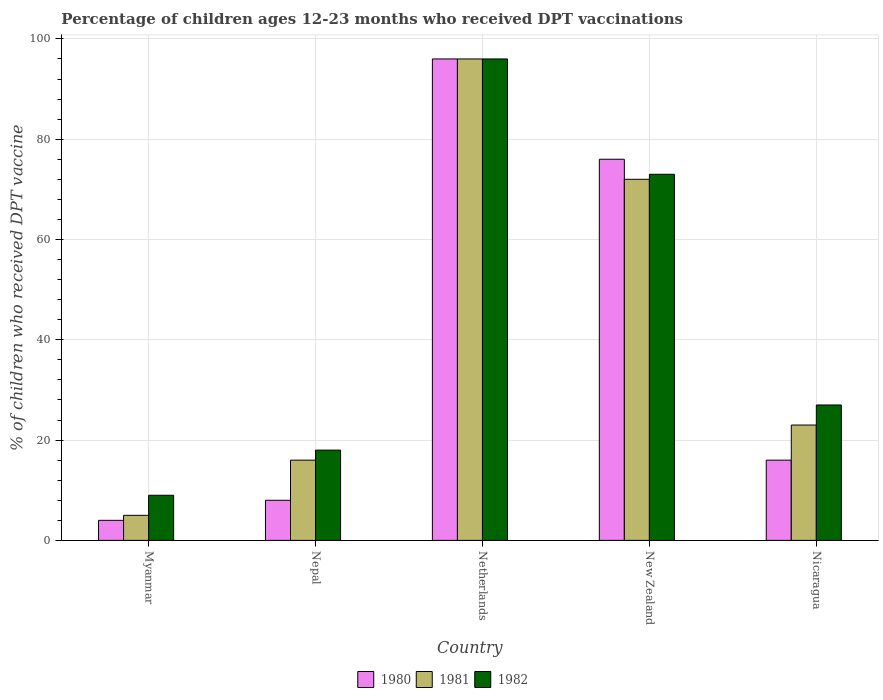How many bars are there on the 5th tick from the right?
Your answer should be very brief. 3. What is the label of the 5th group of bars from the left?
Ensure brevity in your answer.  Nicaragua. Across all countries, what is the maximum percentage of children who received DPT vaccination in 1982?
Make the answer very short. 96. In which country was the percentage of children who received DPT vaccination in 1980 minimum?
Provide a succinct answer. Myanmar. What is the total percentage of children who received DPT vaccination in 1981 in the graph?
Provide a succinct answer. 212. What is the average percentage of children who received DPT vaccination in 1982 per country?
Offer a very short reply. 44.6. What is the difference between the percentage of children who received DPT vaccination of/in 1981 and percentage of children who received DPT vaccination of/in 1982 in Nepal?
Ensure brevity in your answer.  -2. What is the ratio of the percentage of children who received DPT vaccination in 1980 in Myanmar to that in New Zealand?
Make the answer very short. 0.05. What is the difference between the highest and the lowest percentage of children who received DPT vaccination in 1980?
Ensure brevity in your answer.  92. Is the sum of the percentage of children who received DPT vaccination in 1980 in Nepal and New Zealand greater than the maximum percentage of children who received DPT vaccination in 1981 across all countries?
Your response must be concise. No. Are all the bars in the graph horizontal?
Ensure brevity in your answer.  No. How many countries are there in the graph?
Give a very brief answer. 5. What is the difference between two consecutive major ticks on the Y-axis?
Keep it short and to the point. 20. Does the graph contain any zero values?
Make the answer very short. No. What is the title of the graph?
Give a very brief answer. Percentage of children ages 12-23 months who received DPT vaccinations. What is the label or title of the Y-axis?
Make the answer very short. % of children who received DPT vaccine. What is the % of children who received DPT vaccine in 1981 in Myanmar?
Your answer should be compact. 5. What is the % of children who received DPT vaccine of 1980 in Nepal?
Your answer should be compact. 8. What is the % of children who received DPT vaccine in 1982 in Nepal?
Keep it short and to the point. 18. What is the % of children who received DPT vaccine in 1980 in Netherlands?
Offer a very short reply. 96. What is the % of children who received DPT vaccine in 1981 in Netherlands?
Give a very brief answer. 96. What is the % of children who received DPT vaccine in 1982 in Netherlands?
Your answer should be compact. 96. What is the % of children who received DPT vaccine in 1981 in New Zealand?
Provide a succinct answer. 72. What is the % of children who received DPT vaccine in 1982 in New Zealand?
Your answer should be very brief. 73. What is the % of children who received DPT vaccine in 1981 in Nicaragua?
Give a very brief answer. 23. What is the % of children who received DPT vaccine of 1982 in Nicaragua?
Make the answer very short. 27. Across all countries, what is the maximum % of children who received DPT vaccine in 1980?
Make the answer very short. 96. Across all countries, what is the maximum % of children who received DPT vaccine of 1981?
Your response must be concise. 96. Across all countries, what is the maximum % of children who received DPT vaccine of 1982?
Provide a succinct answer. 96. Across all countries, what is the minimum % of children who received DPT vaccine of 1980?
Offer a very short reply. 4. Across all countries, what is the minimum % of children who received DPT vaccine in 1981?
Keep it short and to the point. 5. Across all countries, what is the minimum % of children who received DPT vaccine in 1982?
Offer a very short reply. 9. What is the total % of children who received DPT vaccine of 1981 in the graph?
Make the answer very short. 212. What is the total % of children who received DPT vaccine of 1982 in the graph?
Your answer should be compact. 223. What is the difference between the % of children who received DPT vaccine in 1980 in Myanmar and that in Nepal?
Provide a short and direct response. -4. What is the difference between the % of children who received DPT vaccine in 1981 in Myanmar and that in Nepal?
Give a very brief answer. -11. What is the difference between the % of children who received DPT vaccine in 1980 in Myanmar and that in Netherlands?
Your answer should be compact. -92. What is the difference between the % of children who received DPT vaccine in 1981 in Myanmar and that in Netherlands?
Offer a terse response. -91. What is the difference between the % of children who received DPT vaccine of 1982 in Myanmar and that in Netherlands?
Ensure brevity in your answer.  -87. What is the difference between the % of children who received DPT vaccine in 1980 in Myanmar and that in New Zealand?
Give a very brief answer. -72. What is the difference between the % of children who received DPT vaccine in 1981 in Myanmar and that in New Zealand?
Your response must be concise. -67. What is the difference between the % of children who received DPT vaccine of 1982 in Myanmar and that in New Zealand?
Offer a terse response. -64. What is the difference between the % of children who received DPT vaccine of 1980 in Myanmar and that in Nicaragua?
Your answer should be very brief. -12. What is the difference between the % of children who received DPT vaccine in 1981 in Myanmar and that in Nicaragua?
Your answer should be very brief. -18. What is the difference between the % of children who received DPT vaccine of 1980 in Nepal and that in Netherlands?
Give a very brief answer. -88. What is the difference between the % of children who received DPT vaccine in 1981 in Nepal and that in Netherlands?
Your answer should be very brief. -80. What is the difference between the % of children who received DPT vaccine of 1982 in Nepal and that in Netherlands?
Provide a short and direct response. -78. What is the difference between the % of children who received DPT vaccine of 1980 in Nepal and that in New Zealand?
Offer a very short reply. -68. What is the difference between the % of children who received DPT vaccine in 1981 in Nepal and that in New Zealand?
Your answer should be very brief. -56. What is the difference between the % of children who received DPT vaccine in 1982 in Nepal and that in New Zealand?
Offer a terse response. -55. What is the difference between the % of children who received DPT vaccine in 1981 in Nepal and that in Nicaragua?
Provide a short and direct response. -7. What is the difference between the % of children who received DPT vaccine of 1980 in New Zealand and that in Nicaragua?
Provide a succinct answer. 60. What is the difference between the % of children who received DPT vaccine in 1981 in New Zealand and that in Nicaragua?
Your answer should be compact. 49. What is the difference between the % of children who received DPT vaccine of 1980 in Myanmar and the % of children who received DPT vaccine of 1981 in Nepal?
Your answer should be very brief. -12. What is the difference between the % of children who received DPT vaccine of 1981 in Myanmar and the % of children who received DPT vaccine of 1982 in Nepal?
Offer a very short reply. -13. What is the difference between the % of children who received DPT vaccine of 1980 in Myanmar and the % of children who received DPT vaccine of 1981 in Netherlands?
Keep it short and to the point. -92. What is the difference between the % of children who received DPT vaccine of 1980 in Myanmar and the % of children who received DPT vaccine of 1982 in Netherlands?
Provide a succinct answer. -92. What is the difference between the % of children who received DPT vaccine in 1981 in Myanmar and the % of children who received DPT vaccine in 1982 in Netherlands?
Your response must be concise. -91. What is the difference between the % of children who received DPT vaccine in 1980 in Myanmar and the % of children who received DPT vaccine in 1981 in New Zealand?
Offer a terse response. -68. What is the difference between the % of children who received DPT vaccine in 1980 in Myanmar and the % of children who received DPT vaccine in 1982 in New Zealand?
Provide a succinct answer. -69. What is the difference between the % of children who received DPT vaccine of 1981 in Myanmar and the % of children who received DPT vaccine of 1982 in New Zealand?
Keep it short and to the point. -68. What is the difference between the % of children who received DPT vaccine of 1980 in Myanmar and the % of children who received DPT vaccine of 1981 in Nicaragua?
Ensure brevity in your answer.  -19. What is the difference between the % of children who received DPT vaccine in 1980 in Myanmar and the % of children who received DPT vaccine in 1982 in Nicaragua?
Offer a very short reply. -23. What is the difference between the % of children who received DPT vaccine in 1981 in Myanmar and the % of children who received DPT vaccine in 1982 in Nicaragua?
Ensure brevity in your answer.  -22. What is the difference between the % of children who received DPT vaccine in 1980 in Nepal and the % of children who received DPT vaccine in 1981 in Netherlands?
Offer a very short reply. -88. What is the difference between the % of children who received DPT vaccine in 1980 in Nepal and the % of children who received DPT vaccine in 1982 in Netherlands?
Ensure brevity in your answer.  -88. What is the difference between the % of children who received DPT vaccine in 1981 in Nepal and the % of children who received DPT vaccine in 1982 in Netherlands?
Offer a very short reply. -80. What is the difference between the % of children who received DPT vaccine of 1980 in Nepal and the % of children who received DPT vaccine of 1981 in New Zealand?
Your response must be concise. -64. What is the difference between the % of children who received DPT vaccine of 1980 in Nepal and the % of children who received DPT vaccine of 1982 in New Zealand?
Offer a terse response. -65. What is the difference between the % of children who received DPT vaccine of 1981 in Nepal and the % of children who received DPT vaccine of 1982 in New Zealand?
Provide a succinct answer. -57. What is the difference between the % of children who received DPT vaccine of 1980 in Nepal and the % of children who received DPT vaccine of 1982 in Nicaragua?
Your answer should be very brief. -19. What is the difference between the % of children who received DPT vaccine in 1981 in Nepal and the % of children who received DPT vaccine in 1982 in Nicaragua?
Your response must be concise. -11. What is the difference between the % of children who received DPT vaccine in 1980 in Netherlands and the % of children who received DPT vaccine in 1981 in Nicaragua?
Your answer should be very brief. 73. What is the difference between the % of children who received DPT vaccine in 1980 in New Zealand and the % of children who received DPT vaccine in 1981 in Nicaragua?
Offer a very short reply. 53. What is the difference between the % of children who received DPT vaccine in 1981 in New Zealand and the % of children who received DPT vaccine in 1982 in Nicaragua?
Provide a short and direct response. 45. What is the average % of children who received DPT vaccine of 1980 per country?
Give a very brief answer. 40. What is the average % of children who received DPT vaccine in 1981 per country?
Ensure brevity in your answer.  42.4. What is the average % of children who received DPT vaccine of 1982 per country?
Give a very brief answer. 44.6. What is the difference between the % of children who received DPT vaccine of 1980 and % of children who received DPT vaccine of 1981 in Myanmar?
Give a very brief answer. -1. What is the difference between the % of children who received DPT vaccine in 1980 and % of children who received DPT vaccine in 1982 in Myanmar?
Keep it short and to the point. -5. What is the difference between the % of children who received DPT vaccine in 1981 and % of children who received DPT vaccine in 1982 in Myanmar?
Offer a very short reply. -4. What is the difference between the % of children who received DPT vaccine in 1980 and % of children who received DPT vaccine in 1981 in New Zealand?
Offer a terse response. 4. What is the difference between the % of children who received DPT vaccine of 1981 and % of children who received DPT vaccine of 1982 in New Zealand?
Provide a short and direct response. -1. What is the difference between the % of children who received DPT vaccine in 1980 and % of children who received DPT vaccine in 1981 in Nicaragua?
Keep it short and to the point. -7. What is the difference between the % of children who received DPT vaccine in 1980 and % of children who received DPT vaccine in 1982 in Nicaragua?
Keep it short and to the point. -11. What is the ratio of the % of children who received DPT vaccine of 1980 in Myanmar to that in Nepal?
Give a very brief answer. 0.5. What is the ratio of the % of children who received DPT vaccine of 1981 in Myanmar to that in Nepal?
Provide a succinct answer. 0.31. What is the ratio of the % of children who received DPT vaccine in 1982 in Myanmar to that in Nepal?
Your answer should be very brief. 0.5. What is the ratio of the % of children who received DPT vaccine in 1980 in Myanmar to that in Netherlands?
Give a very brief answer. 0.04. What is the ratio of the % of children who received DPT vaccine of 1981 in Myanmar to that in Netherlands?
Provide a short and direct response. 0.05. What is the ratio of the % of children who received DPT vaccine of 1982 in Myanmar to that in Netherlands?
Offer a terse response. 0.09. What is the ratio of the % of children who received DPT vaccine of 1980 in Myanmar to that in New Zealand?
Make the answer very short. 0.05. What is the ratio of the % of children who received DPT vaccine in 1981 in Myanmar to that in New Zealand?
Give a very brief answer. 0.07. What is the ratio of the % of children who received DPT vaccine in 1982 in Myanmar to that in New Zealand?
Offer a very short reply. 0.12. What is the ratio of the % of children who received DPT vaccine of 1981 in Myanmar to that in Nicaragua?
Ensure brevity in your answer.  0.22. What is the ratio of the % of children who received DPT vaccine in 1982 in Myanmar to that in Nicaragua?
Give a very brief answer. 0.33. What is the ratio of the % of children who received DPT vaccine in 1980 in Nepal to that in Netherlands?
Offer a terse response. 0.08. What is the ratio of the % of children who received DPT vaccine of 1981 in Nepal to that in Netherlands?
Your response must be concise. 0.17. What is the ratio of the % of children who received DPT vaccine in 1982 in Nepal to that in Netherlands?
Your answer should be very brief. 0.19. What is the ratio of the % of children who received DPT vaccine of 1980 in Nepal to that in New Zealand?
Offer a very short reply. 0.11. What is the ratio of the % of children who received DPT vaccine of 1981 in Nepal to that in New Zealand?
Offer a very short reply. 0.22. What is the ratio of the % of children who received DPT vaccine in 1982 in Nepal to that in New Zealand?
Give a very brief answer. 0.25. What is the ratio of the % of children who received DPT vaccine of 1981 in Nepal to that in Nicaragua?
Your response must be concise. 0.7. What is the ratio of the % of children who received DPT vaccine in 1980 in Netherlands to that in New Zealand?
Offer a very short reply. 1.26. What is the ratio of the % of children who received DPT vaccine in 1982 in Netherlands to that in New Zealand?
Make the answer very short. 1.32. What is the ratio of the % of children who received DPT vaccine of 1981 in Netherlands to that in Nicaragua?
Make the answer very short. 4.17. What is the ratio of the % of children who received DPT vaccine of 1982 in Netherlands to that in Nicaragua?
Provide a succinct answer. 3.56. What is the ratio of the % of children who received DPT vaccine in 1980 in New Zealand to that in Nicaragua?
Give a very brief answer. 4.75. What is the ratio of the % of children who received DPT vaccine of 1981 in New Zealand to that in Nicaragua?
Give a very brief answer. 3.13. What is the ratio of the % of children who received DPT vaccine of 1982 in New Zealand to that in Nicaragua?
Ensure brevity in your answer.  2.7. What is the difference between the highest and the second highest % of children who received DPT vaccine of 1980?
Provide a short and direct response. 20. What is the difference between the highest and the second highest % of children who received DPT vaccine of 1982?
Offer a very short reply. 23. What is the difference between the highest and the lowest % of children who received DPT vaccine of 1980?
Provide a short and direct response. 92. What is the difference between the highest and the lowest % of children who received DPT vaccine of 1981?
Your response must be concise. 91. What is the difference between the highest and the lowest % of children who received DPT vaccine of 1982?
Provide a succinct answer. 87. 